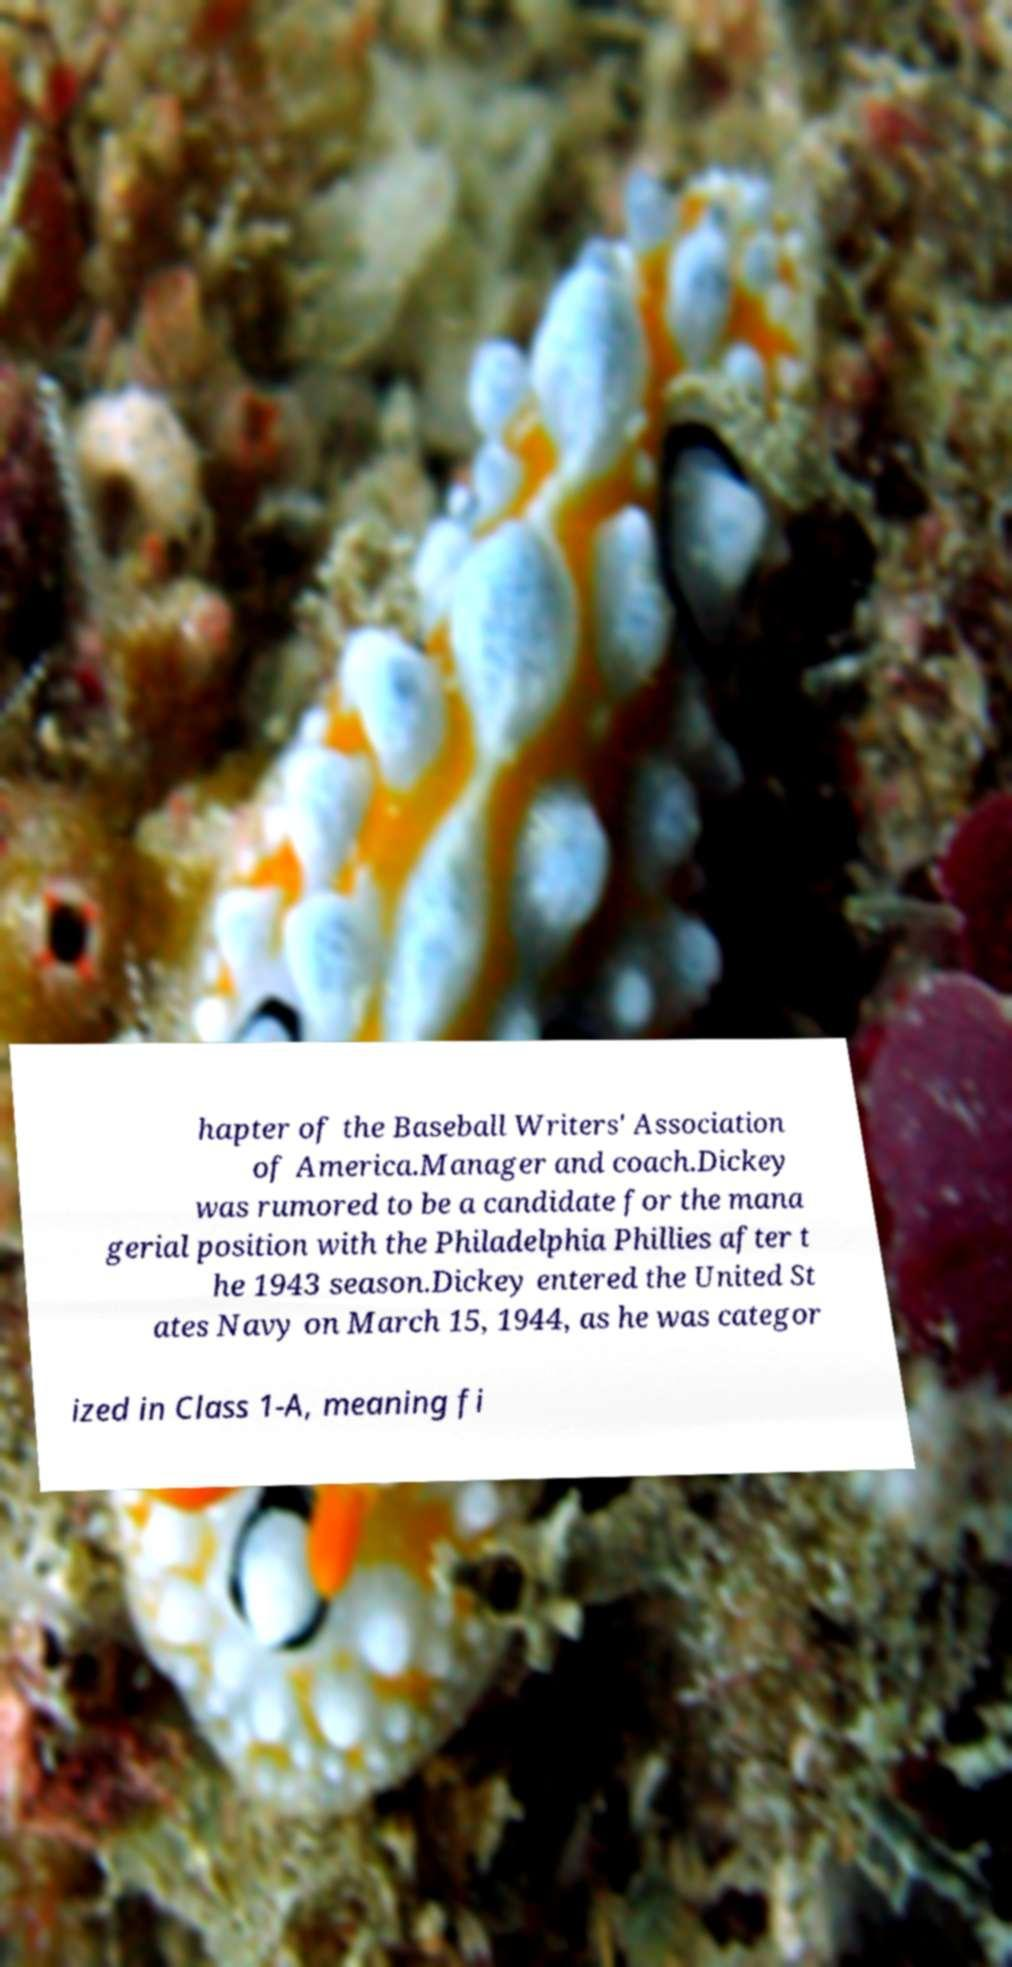There's text embedded in this image that I need extracted. Can you transcribe it verbatim? hapter of the Baseball Writers' Association of America.Manager and coach.Dickey was rumored to be a candidate for the mana gerial position with the Philadelphia Phillies after t he 1943 season.Dickey entered the United St ates Navy on March 15, 1944, as he was categor ized in Class 1-A, meaning fi 